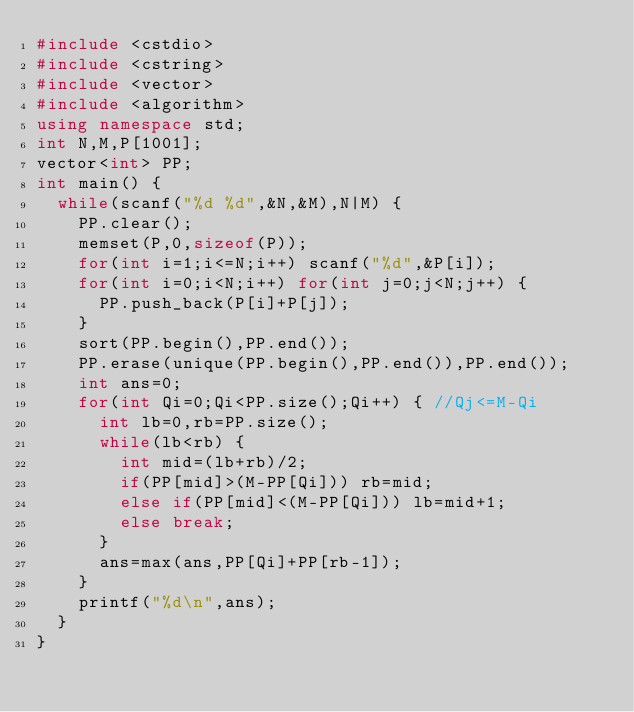<code> <loc_0><loc_0><loc_500><loc_500><_C++_>#include <cstdio>
#include <cstring>
#include <vector>
#include <algorithm>
using namespace std;
int N,M,P[1001];
vector<int> PP;
int main() {
	while(scanf("%d %d",&N,&M),N|M) {
		PP.clear();
		memset(P,0,sizeof(P));
		for(int i=1;i<=N;i++) scanf("%d",&P[i]);
		for(int i=0;i<N;i++) for(int j=0;j<N;j++) {
			PP.push_back(P[i]+P[j]);
		}
		sort(PP.begin(),PP.end());
		PP.erase(unique(PP.begin(),PP.end()),PP.end());
		int ans=0;
		for(int Qi=0;Qi<PP.size();Qi++) { //Qj<=M-Qi
			int lb=0,rb=PP.size();
			while(lb<rb) {
				int mid=(lb+rb)/2;
				if(PP[mid]>(M-PP[Qi])) rb=mid;
				else if(PP[mid]<(M-PP[Qi])) lb=mid+1;
				else break;
			}
			ans=max(ans,PP[Qi]+PP[rb-1]);
		}
		printf("%d\n",ans);
	}
}</code> 